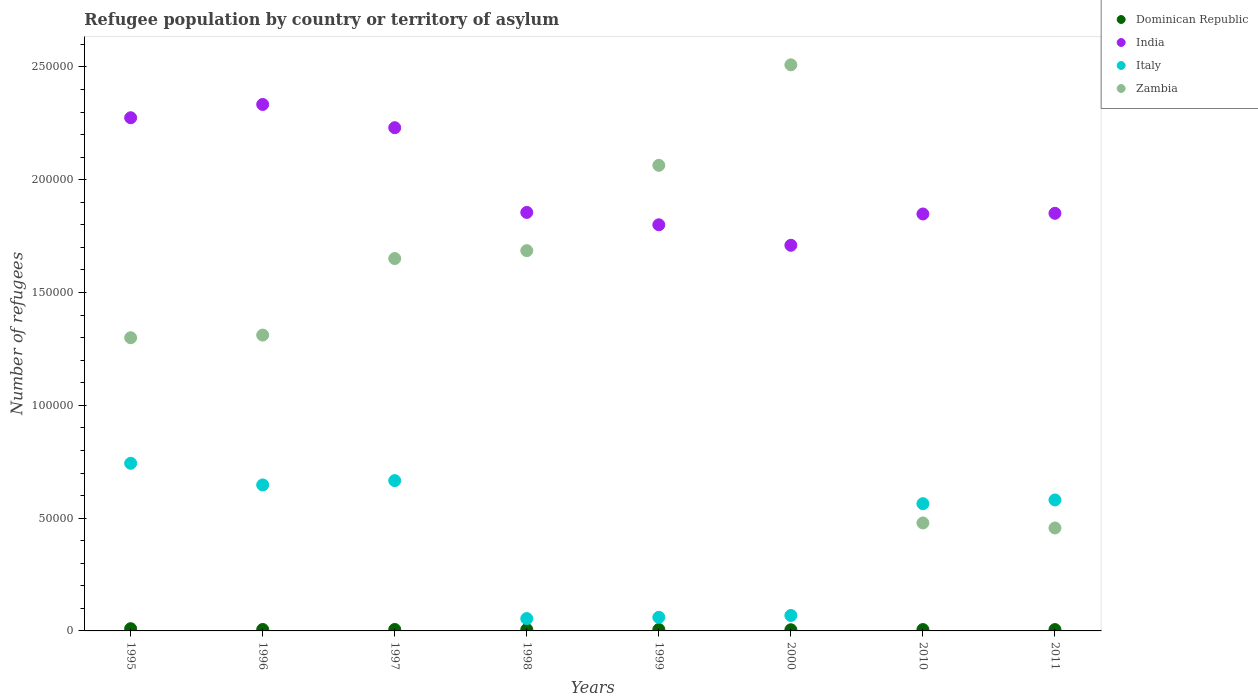How many different coloured dotlines are there?
Ensure brevity in your answer.  4. Is the number of dotlines equal to the number of legend labels?
Make the answer very short. Yes. What is the number of refugees in Zambia in 1998?
Your answer should be compact. 1.69e+05. Across all years, what is the maximum number of refugees in Italy?
Ensure brevity in your answer.  7.43e+04. Across all years, what is the minimum number of refugees in India?
Provide a short and direct response. 1.71e+05. In which year was the number of refugees in Zambia minimum?
Your answer should be very brief. 2011. What is the total number of refugees in Dominican Republic in the graph?
Offer a very short reply. 5206. What is the difference between the number of refugees in Zambia in 1999 and that in 2000?
Offer a very short reply. -4.46e+04. What is the difference between the number of refugees in Italy in 1999 and the number of refugees in India in 2000?
Keep it short and to the point. -1.65e+05. What is the average number of refugees in Dominican Republic per year?
Keep it short and to the point. 650.75. In the year 2011, what is the difference between the number of refugees in Italy and number of refugees in India?
Ensure brevity in your answer.  -1.27e+05. In how many years, is the number of refugees in Italy greater than 220000?
Ensure brevity in your answer.  0. What is the ratio of the number of refugees in Italy in 1999 to that in 2000?
Offer a terse response. 0.88. Is the number of refugees in Zambia in 1996 less than that in 2010?
Your answer should be very brief. No. Is the difference between the number of refugees in Italy in 1999 and 2000 greater than the difference between the number of refugees in India in 1999 and 2000?
Give a very brief answer. No. What is the difference between the highest and the second highest number of refugees in Italy?
Give a very brief answer. 7682. What is the difference between the highest and the lowest number of refugees in India?
Give a very brief answer. 6.24e+04. In how many years, is the number of refugees in India greater than the average number of refugees in India taken over all years?
Give a very brief answer. 3. Is it the case that in every year, the sum of the number of refugees in Zambia and number of refugees in India  is greater than the sum of number of refugees in Dominican Republic and number of refugees in Italy?
Offer a terse response. No. Does the number of refugees in Zambia monotonically increase over the years?
Keep it short and to the point. No. Is the number of refugees in Zambia strictly greater than the number of refugees in Italy over the years?
Your answer should be very brief. No. How many years are there in the graph?
Offer a terse response. 8. Does the graph contain any zero values?
Provide a short and direct response. No. What is the title of the graph?
Offer a terse response. Refugee population by country or territory of asylum. What is the label or title of the Y-axis?
Make the answer very short. Number of refugees. What is the Number of refugees in Dominican Republic in 1995?
Keep it short and to the point. 985. What is the Number of refugees of India in 1995?
Your answer should be very brief. 2.27e+05. What is the Number of refugees of Italy in 1995?
Provide a short and direct response. 7.43e+04. What is the Number of refugees in Zambia in 1995?
Your answer should be very brief. 1.30e+05. What is the Number of refugees in Dominican Republic in 1996?
Offer a terse response. 640. What is the Number of refugees of India in 1996?
Make the answer very short. 2.33e+05. What is the Number of refugees of Italy in 1996?
Keep it short and to the point. 6.47e+04. What is the Number of refugees of Zambia in 1996?
Make the answer very short. 1.31e+05. What is the Number of refugees in Dominican Republic in 1997?
Your answer should be very brief. 638. What is the Number of refugees in India in 1997?
Offer a very short reply. 2.23e+05. What is the Number of refugees in Italy in 1997?
Provide a short and direct response. 6.66e+04. What is the Number of refugees in Zambia in 1997?
Offer a terse response. 1.65e+05. What is the Number of refugees in Dominican Republic in 1998?
Offer a very short reply. 614. What is the Number of refugees in India in 1998?
Offer a terse response. 1.86e+05. What is the Number of refugees in Italy in 1998?
Provide a succinct answer. 5473. What is the Number of refugees in Zambia in 1998?
Your answer should be compact. 1.69e+05. What is the Number of refugees of Dominican Republic in 1999?
Offer a terse response. 625. What is the Number of refugees of India in 1999?
Your response must be concise. 1.80e+05. What is the Number of refugees in Italy in 1999?
Your response must be concise. 6024. What is the Number of refugees of Zambia in 1999?
Provide a succinct answer. 2.06e+05. What is the Number of refugees in Dominican Republic in 2000?
Your answer should be very brief. 510. What is the Number of refugees in India in 2000?
Your response must be concise. 1.71e+05. What is the Number of refugees of Italy in 2000?
Ensure brevity in your answer.  6849. What is the Number of refugees in Zambia in 2000?
Your response must be concise. 2.51e+05. What is the Number of refugees in Dominican Republic in 2010?
Provide a succinct answer. 599. What is the Number of refugees of India in 2010?
Keep it short and to the point. 1.85e+05. What is the Number of refugees of Italy in 2010?
Give a very brief answer. 5.64e+04. What is the Number of refugees of Zambia in 2010?
Offer a terse response. 4.79e+04. What is the Number of refugees of Dominican Republic in 2011?
Provide a succinct answer. 595. What is the Number of refugees in India in 2011?
Your answer should be compact. 1.85e+05. What is the Number of refugees of Italy in 2011?
Offer a very short reply. 5.81e+04. What is the Number of refugees of Zambia in 2011?
Ensure brevity in your answer.  4.56e+04. Across all years, what is the maximum Number of refugees of Dominican Republic?
Offer a terse response. 985. Across all years, what is the maximum Number of refugees of India?
Provide a succinct answer. 2.33e+05. Across all years, what is the maximum Number of refugees in Italy?
Give a very brief answer. 7.43e+04. Across all years, what is the maximum Number of refugees of Zambia?
Offer a very short reply. 2.51e+05. Across all years, what is the minimum Number of refugees of Dominican Republic?
Your answer should be very brief. 510. Across all years, what is the minimum Number of refugees in India?
Offer a terse response. 1.71e+05. Across all years, what is the minimum Number of refugees of Italy?
Your answer should be compact. 5473. Across all years, what is the minimum Number of refugees in Zambia?
Keep it short and to the point. 4.56e+04. What is the total Number of refugees in Dominican Republic in the graph?
Offer a very short reply. 5206. What is the total Number of refugees of India in the graph?
Your answer should be compact. 1.59e+06. What is the total Number of refugees of Italy in the graph?
Your answer should be compact. 3.38e+05. What is the total Number of refugees in Zambia in the graph?
Your answer should be very brief. 1.15e+06. What is the difference between the Number of refugees of Dominican Republic in 1995 and that in 1996?
Your answer should be compact. 345. What is the difference between the Number of refugees of India in 1995 and that in 1996?
Your answer should be very brief. -5890. What is the difference between the Number of refugees of Italy in 1995 and that in 1996?
Provide a short and direct response. 9591. What is the difference between the Number of refugees of Zambia in 1995 and that in 1996?
Your answer should be very brief. -1174. What is the difference between the Number of refugees in Dominican Republic in 1995 and that in 1997?
Give a very brief answer. 347. What is the difference between the Number of refugees of India in 1995 and that in 1997?
Keep it short and to the point. 4407. What is the difference between the Number of refugees of Italy in 1995 and that in 1997?
Ensure brevity in your answer.  7682. What is the difference between the Number of refugees in Zambia in 1995 and that in 1997?
Your answer should be compact. -3.51e+04. What is the difference between the Number of refugees in Dominican Republic in 1995 and that in 1998?
Offer a terse response. 371. What is the difference between the Number of refugees in India in 1995 and that in 1998?
Your answer should be very brief. 4.20e+04. What is the difference between the Number of refugees in Italy in 1995 and that in 1998?
Offer a terse response. 6.88e+04. What is the difference between the Number of refugees of Zambia in 1995 and that in 1998?
Ensure brevity in your answer.  -3.86e+04. What is the difference between the Number of refugees in Dominican Republic in 1995 and that in 1999?
Offer a very short reply. 360. What is the difference between the Number of refugees in India in 1995 and that in 1999?
Offer a terse response. 4.74e+04. What is the difference between the Number of refugees in Italy in 1995 and that in 1999?
Keep it short and to the point. 6.83e+04. What is the difference between the Number of refugees in Zambia in 1995 and that in 1999?
Your answer should be very brief. -7.64e+04. What is the difference between the Number of refugees in Dominican Republic in 1995 and that in 2000?
Give a very brief answer. 475. What is the difference between the Number of refugees of India in 1995 and that in 2000?
Provide a succinct answer. 5.65e+04. What is the difference between the Number of refugees in Italy in 1995 and that in 2000?
Provide a short and direct response. 6.75e+04. What is the difference between the Number of refugees of Zambia in 1995 and that in 2000?
Your answer should be compact. -1.21e+05. What is the difference between the Number of refugees in Dominican Republic in 1995 and that in 2010?
Provide a succinct answer. 386. What is the difference between the Number of refugees in India in 1995 and that in 2010?
Your answer should be very brief. 4.27e+04. What is the difference between the Number of refugees of Italy in 1995 and that in 2010?
Your response must be concise. 1.79e+04. What is the difference between the Number of refugees in Zambia in 1995 and that in 2010?
Give a very brief answer. 8.21e+04. What is the difference between the Number of refugees of Dominican Republic in 1995 and that in 2011?
Your response must be concise. 390. What is the difference between the Number of refugees in India in 1995 and that in 2011?
Give a very brief answer. 4.24e+04. What is the difference between the Number of refugees in Italy in 1995 and that in 2011?
Your answer should be compact. 1.62e+04. What is the difference between the Number of refugees in Zambia in 1995 and that in 2011?
Ensure brevity in your answer.  8.43e+04. What is the difference between the Number of refugees of Dominican Republic in 1996 and that in 1997?
Keep it short and to the point. 2. What is the difference between the Number of refugees of India in 1996 and that in 1997?
Make the answer very short. 1.03e+04. What is the difference between the Number of refugees of Italy in 1996 and that in 1997?
Offer a terse response. -1909. What is the difference between the Number of refugees in Zambia in 1996 and that in 1997?
Provide a short and direct response. -3.39e+04. What is the difference between the Number of refugees in Dominican Republic in 1996 and that in 1998?
Offer a terse response. 26. What is the difference between the Number of refugees of India in 1996 and that in 1998?
Provide a short and direct response. 4.79e+04. What is the difference between the Number of refugees in Italy in 1996 and that in 1998?
Offer a very short reply. 5.92e+04. What is the difference between the Number of refugees in Zambia in 1996 and that in 1998?
Give a very brief answer. -3.74e+04. What is the difference between the Number of refugees of India in 1996 and that in 1999?
Offer a terse response. 5.33e+04. What is the difference between the Number of refugees in Italy in 1996 and that in 1999?
Keep it short and to the point. 5.87e+04. What is the difference between the Number of refugees of Zambia in 1996 and that in 1999?
Provide a short and direct response. -7.52e+04. What is the difference between the Number of refugees of Dominican Republic in 1996 and that in 2000?
Ensure brevity in your answer.  130. What is the difference between the Number of refugees of India in 1996 and that in 2000?
Provide a short and direct response. 6.24e+04. What is the difference between the Number of refugees in Italy in 1996 and that in 2000?
Your response must be concise. 5.79e+04. What is the difference between the Number of refugees in Zambia in 1996 and that in 2000?
Your answer should be compact. -1.20e+05. What is the difference between the Number of refugees of India in 1996 and that in 2010?
Offer a very short reply. 4.85e+04. What is the difference between the Number of refugees in Italy in 1996 and that in 2010?
Provide a short and direct response. 8314. What is the difference between the Number of refugees in Zambia in 1996 and that in 2010?
Offer a very short reply. 8.33e+04. What is the difference between the Number of refugees in India in 1996 and that in 2011?
Give a very brief answer. 4.83e+04. What is the difference between the Number of refugees in Italy in 1996 and that in 2011?
Your response must be concise. 6651. What is the difference between the Number of refugees of Zambia in 1996 and that in 2011?
Give a very brief answer. 8.55e+04. What is the difference between the Number of refugees of Dominican Republic in 1997 and that in 1998?
Your answer should be compact. 24. What is the difference between the Number of refugees in India in 1997 and that in 1998?
Your answer should be compact. 3.76e+04. What is the difference between the Number of refugees in Italy in 1997 and that in 1998?
Keep it short and to the point. 6.11e+04. What is the difference between the Number of refugees of Zambia in 1997 and that in 1998?
Your answer should be very brief. -3492. What is the difference between the Number of refugees in Dominican Republic in 1997 and that in 1999?
Provide a short and direct response. 13. What is the difference between the Number of refugees of India in 1997 and that in 1999?
Your answer should be very brief. 4.30e+04. What is the difference between the Number of refugees in Italy in 1997 and that in 1999?
Provide a succinct answer. 6.06e+04. What is the difference between the Number of refugees of Zambia in 1997 and that in 1999?
Your answer should be very brief. -4.13e+04. What is the difference between the Number of refugees of Dominican Republic in 1997 and that in 2000?
Keep it short and to the point. 128. What is the difference between the Number of refugees of India in 1997 and that in 2000?
Offer a terse response. 5.21e+04. What is the difference between the Number of refugees of Italy in 1997 and that in 2000?
Your response must be concise. 5.98e+04. What is the difference between the Number of refugees in Zambia in 1997 and that in 2000?
Keep it short and to the point. -8.59e+04. What is the difference between the Number of refugees of India in 1997 and that in 2010?
Offer a terse response. 3.83e+04. What is the difference between the Number of refugees of Italy in 1997 and that in 2010?
Your answer should be compact. 1.02e+04. What is the difference between the Number of refugees of Zambia in 1997 and that in 2010?
Ensure brevity in your answer.  1.17e+05. What is the difference between the Number of refugees of Dominican Republic in 1997 and that in 2011?
Make the answer very short. 43. What is the difference between the Number of refugees in India in 1997 and that in 2011?
Provide a short and direct response. 3.80e+04. What is the difference between the Number of refugees in Italy in 1997 and that in 2011?
Offer a terse response. 8560. What is the difference between the Number of refugees in Zambia in 1997 and that in 2011?
Provide a short and direct response. 1.19e+05. What is the difference between the Number of refugees in Dominican Republic in 1998 and that in 1999?
Offer a very short reply. -11. What is the difference between the Number of refugees of India in 1998 and that in 1999?
Ensure brevity in your answer.  5485. What is the difference between the Number of refugees of Italy in 1998 and that in 1999?
Offer a terse response. -551. What is the difference between the Number of refugees in Zambia in 1998 and that in 1999?
Your response must be concise. -3.78e+04. What is the difference between the Number of refugees in Dominican Republic in 1998 and that in 2000?
Your answer should be compact. 104. What is the difference between the Number of refugees of India in 1998 and that in 2000?
Keep it short and to the point. 1.46e+04. What is the difference between the Number of refugees in Italy in 1998 and that in 2000?
Your response must be concise. -1376. What is the difference between the Number of refugees of Zambia in 1998 and that in 2000?
Provide a short and direct response. -8.24e+04. What is the difference between the Number of refugees of India in 1998 and that in 2010?
Offer a terse response. 695. What is the difference between the Number of refugees in Italy in 1998 and that in 2010?
Your answer should be compact. -5.09e+04. What is the difference between the Number of refugees of Zambia in 1998 and that in 2010?
Make the answer very short. 1.21e+05. What is the difference between the Number of refugees of India in 1998 and that in 2011?
Your answer should be very brief. 398. What is the difference between the Number of refugees in Italy in 1998 and that in 2011?
Ensure brevity in your answer.  -5.26e+04. What is the difference between the Number of refugees in Zambia in 1998 and that in 2011?
Make the answer very short. 1.23e+05. What is the difference between the Number of refugees of Dominican Republic in 1999 and that in 2000?
Your response must be concise. 115. What is the difference between the Number of refugees in India in 1999 and that in 2000?
Offer a terse response. 9090. What is the difference between the Number of refugees in Italy in 1999 and that in 2000?
Your answer should be compact. -825. What is the difference between the Number of refugees of Zambia in 1999 and that in 2000?
Your response must be concise. -4.46e+04. What is the difference between the Number of refugees in Dominican Republic in 1999 and that in 2010?
Your answer should be compact. 26. What is the difference between the Number of refugees of India in 1999 and that in 2010?
Your answer should be very brief. -4790. What is the difference between the Number of refugees in Italy in 1999 and that in 2010?
Provide a short and direct response. -5.04e+04. What is the difference between the Number of refugees in Zambia in 1999 and that in 2010?
Give a very brief answer. 1.59e+05. What is the difference between the Number of refugees of Dominican Republic in 1999 and that in 2011?
Your answer should be compact. 30. What is the difference between the Number of refugees of India in 1999 and that in 2011?
Keep it short and to the point. -5087. What is the difference between the Number of refugees in Italy in 1999 and that in 2011?
Keep it short and to the point. -5.20e+04. What is the difference between the Number of refugees in Zambia in 1999 and that in 2011?
Keep it short and to the point. 1.61e+05. What is the difference between the Number of refugees in Dominican Republic in 2000 and that in 2010?
Offer a terse response. -89. What is the difference between the Number of refugees in India in 2000 and that in 2010?
Your answer should be compact. -1.39e+04. What is the difference between the Number of refugees of Italy in 2000 and that in 2010?
Provide a succinct answer. -4.95e+04. What is the difference between the Number of refugees of Zambia in 2000 and that in 2010?
Your answer should be very brief. 2.03e+05. What is the difference between the Number of refugees in Dominican Republic in 2000 and that in 2011?
Provide a succinct answer. -85. What is the difference between the Number of refugees of India in 2000 and that in 2011?
Ensure brevity in your answer.  -1.42e+04. What is the difference between the Number of refugees in Italy in 2000 and that in 2011?
Your answer should be compact. -5.12e+04. What is the difference between the Number of refugees of Zambia in 2000 and that in 2011?
Give a very brief answer. 2.05e+05. What is the difference between the Number of refugees of India in 2010 and that in 2011?
Provide a succinct answer. -297. What is the difference between the Number of refugees of Italy in 2010 and that in 2011?
Ensure brevity in your answer.  -1663. What is the difference between the Number of refugees in Zambia in 2010 and that in 2011?
Make the answer very short. 2225. What is the difference between the Number of refugees of Dominican Republic in 1995 and the Number of refugees of India in 1996?
Your response must be concise. -2.32e+05. What is the difference between the Number of refugees of Dominican Republic in 1995 and the Number of refugees of Italy in 1996?
Ensure brevity in your answer.  -6.37e+04. What is the difference between the Number of refugees of Dominican Republic in 1995 and the Number of refugees of Zambia in 1996?
Offer a very short reply. -1.30e+05. What is the difference between the Number of refugees in India in 1995 and the Number of refugees in Italy in 1996?
Offer a very short reply. 1.63e+05. What is the difference between the Number of refugees of India in 1995 and the Number of refugees of Zambia in 1996?
Give a very brief answer. 9.63e+04. What is the difference between the Number of refugees in Italy in 1995 and the Number of refugees in Zambia in 1996?
Ensure brevity in your answer.  -5.68e+04. What is the difference between the Number of refugees of Dominican Republic in 1995 and the Number of refugees of India in 1997?
Your answer should be very brief. -2.22e+05. What is the difference between the Number of refugees in Dominican Republic in 1995 and the Number of refugees in Italy in 1997?
Your answer should be compact. -6.56e+04. What is the difference between the Number of refugees of Dominican Republic in 1995 and the Number of refugees of Zambia in 1997?
Offer a very short reply. -1.64e+05. What is the difference between the Number of refugees of India in 1995 and the Number of refugees of Italy in 1997?
Your answer should be very brief. 1.61e+05. What is the difference between the Number of refugees in India in 1995 and the Number of refugees in Zambia in 1997?
Keep it short and to the point. 6.24e+04. What is the difference between the Number of refugees of Italy in 1995 and the Number of refugees of Zambia in 1997?
Keep it short and to the point. -9.08e+04. What is the difference between the Number of refugees in Dominican Republic in 1995 and the Number of refugees in India in 1998?
Your answer should be very brief. -1.85e+05. What is the difference between the Number of refugees of Dominican Republic in 1995 and the Number of refugees of Italy in 1998?
Make the answer very short. -4488. What is the difference between the Number of refugees of Dominican Republic in 1995 and the Number of refugees of Zambia in 1998?
Offer a terse response. -1.68e+05. What is the difference between the Number of refugees in India in 1995 and the Number of refugees in Italy in 1998?
Your answer should be very brief. 2.22e+05. What is the difference between the Number of refugees in India in 1995 and the Number of refugees in Zambia in 1998?
Your response must be concise. 5.89e+04. What is the difference between the Number of refugees of Italy in 1995 and the Number of refugees of Zambia in 1998?
Offer a terse response. -9.43e+04. What is the difference between the Number of refugees in Dominican Republic in 1995 and the Number of refugees in India in 1999?
Your answer should be very brief. -1.79e+05. What is the difference between the Number of refugees of Dominican Republic in 1995 and the Number of refugees of Italy in 1999?
Make the answer very short. -5039. What is the difference between the Number of refugees of Dominican Republic in 1995 and the Number of refugees of Zambia in 1999?
Offer a very short reply. -2.05e+05. What is the difference between the Number of refugees in India in 1995 and the Number of refugees in Italy in 1999?
Your answer should be compact. 2.21e+05. What is the difference between the Number of refugees of India in 1995 and the Number of refugees of Zambia in 1999?
Keep it short and to the point. 2.11e+04. What is the difference between the Number of refugees of Italy in 1995 and the Number of refugees of Zambia in 1999?
Offer a terse response. -1.32e+05. What is the difference between the Number of refugees in Dominican Republic in 1995 and the Number of refugees in India in 2000?
Offer a very short reply. -1.70e+05. What is the difference between the Number of refugees in Dominican Republic in 1995 and the Number of refugees in Italy in 2000?
Provide a short and direct response. -5864. What is the difference between the Number of refugees in Dominican Republic in 1995 and the Number of refugees in Zambia in 2000?
Make the answer very short. -2.50e+05. What is the difference between the Number of refugees of India in 1995 and the Number of refugees of Italy in 2000?
Your response must be concise. 2.21e+05. What is the difference between the Number of refugees in India in 1995 and the Number of refugees in Zambia in 2000?
Make the answer very short. -2.35e+04. What is the difference between the Number of refugees of Italy in 1995 and the Number of refugees of Zambia in 2000?
Provide a short and direct response. -1.77e+05. What is the difference between the Number of refugees in Dominican Republic in 1995 and the Number of refugees in India in 2010?
Give a very brief answer. -1.84e+05. What is the difference between the Number of refugees in Dominican Republic in 1995 and the Number of refugees in Italy in 2010?
Your answer should be compact. -5.54e+04. What is the difference between the Number of refugees in Dominican Republic in 1995 and the Number of refugees in Zambia in 2010?
Make the answer very short. -4.69e+04. What is the difference between the Number of refugees in India in 1995 and the Number of refugees in Italy in 2010?
Your answer should be very brief. 1.71e+05. What is the difference between the Number of refugees in India in 1995 and the Number of refugees in Zambia in 2010?
Provide a succinct answer. 1.80e+05. What is the difference between the Number of refugees in Italy in 1995 and the Number of refugees in Zambia in 2010?
Offer a terse response. 2.64e+04. What is the difference between the Number of refugees of Dominican Republic in 1995 and the Number of refugees of India in 2011?
Provide a short and direct response. -1.84e+05. What is the difference between the Number of refugees of Dominican Republic in 1995 and the Number of refugees of Italy in 2011?
Keep it short and to the point. -5.71e+04. What is the difference between the Number of refugees of Dominican Republic in 1995 and the Number of refugees of Zambia in 2011?
Offer a terse response. -4.46e+04. What is the difference between the Number of refugees of India in 1995 and the Number of refugees of Italy in 2011?
Keep it short and to the point. 1.69e+05. What is the difference between the Number of refugees of India in 1995 and the Number of refugees of Zambia in 2011?
Give a very brief answer. 1.82e+05. What is the difference between the Number of refugees of Italy in 1995 and the Number of refugees of Zambia in 2011?
Your answer should be compact. 2.87e+04. What is the difference between the Number of refugees of Dominican Republic in 1996 and the Number of refugees of India in 1997?
Offer a very short reply. -2.22e+05. What is the difference between the Number of refugees in Dominican Republic in 1996 and the Number of refugees in Italy in 1997?
Ensure brevity in your answer.  -6.60e+04. What is the difference between the Number of refugees in Dominican Republic in 1996 and the Number of refugees in Zambia in 1997?
Offer a terse response. -1.64e+05. What is the difference between the Number of refugees of India in 1996 and the Number of refugees of Italy in 1997?
Give a very brief answer. 1.67e+05. What is the difference between the Number of refugees of India in 1996 and the Number of refugees of Zambia in 1997?
Your answer should be compact. 6.83e+04. What is the difference between the Number of refugees in Italy in 1996 and the Number of refugees in Zambia in 1997?
Offer a very short reply. -1.00e+05. What is the difference between the Number of refugees of Dominican Republic in 1996 and the Number of refugees of India in 1998?
Ensure brevity in your answer.  -1.85e+05. What is the difference between the Number of refugees of Dominican Republic in 1996 and the Number of refugees of Italy in 1998?
Ensure brevity in your answer.  -4833. What is the difference between the Number of refugees of Dominican Republic in 1996 and the Number of refugees of Zambia in 1998?
Offer a very short reply. -1.68e+05. What is the difference between the Number of refugees of India in 1996 and the Number of refugees of Italy in 1998?
Make the answer very short. 2.28e+05. What is the difference between the Number of refugees in India in 1996 and the Number of refugees in Zambia in 1998?
Your answer should be very brief. 6.48e+04. What is the difference between the Number of refugees in Italy in 1996 and the Number of refugees in Zambia in 1998?
Offer a very short reply. -1.04e+05. What is the difference between the Number of refugees of Dominican Republic in 1996 and the Number of refugees of India in 1999?
Your answer should be very brief. -1.79e+05. What is the difference between the Number of refugees of Dominican Republic in 1996 and the Number of refugees of Italy in 1999?
Provide a short and direct response. -5384. What is the difference between the Number of refugees of Dominican Republic in 1996 and the Number of refugees of Zambia in 1999?
Your answer should be very brief. -2.06e+05. What is the difference between the Number of refugees of India in 1996 and the Number of refugees of Italy in 1999?
Provide a short and direct response. 2.27e+05. What is the difference between the Number of refugees of India in 1996 and the Number of refugees of Zambia in 1999?
Make the answer very short. 2.70e+04. What is the difference between the Number of refugees in Italy in 1996 and the Number of refugees in Zambia in 1999?
Provide a short and direct response. -1.42e+05. What is the difference between the Number of refugees of Dominican Republic in 1996 and the Number of refugees of India in 2000?
Make the answer very short. -1.70e+05. What is the difference between the Number of refugees in Dominican Republic in 1996 and the Number of refugees in Italy in 2000?
Your answer should be very brief. -6209. What is the difference between the Number of refugees of Dominican Republic in 1996 and the Number of refugees of Zambia in 2000?
Provide a succinct answer. -2.50e+05. What is the difference between the Number of refugees of India in 1996 and the Number of refugees of Italy in 2000?
Provide a short and direct response. 2.27e+05. What is the difference between the Number of refugees of India in 1996 and the Number of refugees of Zambia in 2000?
Give a very brief answer. -1.76e+04. What is the difference between the Number of refugees of Italy in 1996 and the Number of refugees of Zambia in 2000?
Offer a very short reply. -1.86e+05. What is the difference between the Number of refugees in Dominican Republic in 1996 and the Number of refugees in India in 2010?
Your answer should be very brief. -1.84e+05. What is the difference between the Number of refugees in Dominican Republic in 1996 and the Number of refugees in Italy in 2010?
Offer a terse response. -5.58e+04. What is the difference between the Number of refugees in Dominican Republic in 1996 and the Number of refugees in Zambia in 2010?
Keep it short and to the point. -4.72e+04. What is the difference between the Number of refugees in India in 1996 and the Number of refugees in Italy in 2010?
Give a very brief answer. 1.77e+05. What is the difference between the Number of refugees in India in 1996 and the Number of refugees in Zambia in 2010?
Provide a short and direct response. 1.86e+05. What is the difference between the Number of refugees of Italy in 1996 and the Number of refugees of Zambia in 2010?
Your response must be concise. 1.69e+04. What is the difference between the Number of refugees in Dominican Republic in 1996 and the Number of refugees in India in 2011?
Ensure brevity in your answer.  -1.84e+05. What is the difference between the Number of refugees in Dominican Republic in 1996 and the Number of refugees in Italy in 2011?
Provide a short and direct response. -5.74e+04. What is the difference between the Number of refugees of Dominican Republic in 1996 and the Number of refugees of Zambia in 2011?
Give a very brief answer. -4.50e+04. What is the difference between the Number of refugees in India in 1996 and the Number of refugees in Italy in 2011?
Provide a succinct answer. 1.75e+05. What is the difference between the Number of refugees of India in 1996 and the Number of refugees of Zambia in 2011?
Provide a succinct answer. 1.88e+05. What is the difference between the Number of refugees of Italy in 1996 and the Number of refugees of Zambia in 2011?
Give a very brief answer. 1.91e+04. What is the difference between the Number of refugees in Dominican Republic in 1997 and the Number of refugees in India in 1998?
Provide a succinct answer. -1.85e+05. What is the difference between the Number of refugees of Dominican Republic in 1997 and the Number of refugees of Italy in 1998?
Provide a short and direct response. -4835. What is the difference between the Number of refugees of Dominican Republic in 1997 and the Number of refugees of Zambia in 1998?
Keep it short and to the point. -1.68e+05. What is the difference between the Number of refugees of India in 1997 and the Number of refugees of Italy in 1998?
Ensure brevity in your answer.  2.18e+05. What is the difference between the Number of refugees in India in 1997 and the Number of refugees in Zambia in 1998?
Your response must be concise. 5.45e+04. What is the difference between the Number of refugees of Italy in 1997 and the Number of refugees of Zambia in 1998?
Offer a very short reply. -1.02e+05. What is the difference between the Number of refugees of Dominican Republic in 1997 and the Number of refugees of India in 1999?
Provide a succinct answer. -1.79e+05. What is the difference between the Number of refugees of Dominican Republic in 1997 and the Number of refugees of Italy in 1999?
Offer a very short reply. -5386. What is the difference between the Number of refugees in Dominican Republic in 1997 and the Number of refugees in Zambia in 1999?
Provide a succinct answer. -2.06e+05. What is the difference between the Number of refugees of India in 1997 and the Number of refugees of Italy in 1999?
Your answer should be very brief. 2.17e+05. What is the difference between the Number of refugees of India in 1997 and the Number of refugees of Zambia in 1999?
Provide a short and direct response. 1.67e+04. What is the difference between the Number of refugees in Italy in 1997 and the Number of refugees in Zambia in 1999?
Make the answer very short. -1.40e+05. What is the difference between the Number of refugees of Dominican Republic in 1997 and the Number of refugees of India in 2000?
Offer a very short reply. -1.70e+05. What is the difference between the Number of refugees in Dominican Republic in 1997 and the Number of refugees in Italy in 2000?
Offer a terse response. -6211. What is the difference between the Number of refugees of Dominican Republic in 1997 and the Number of refugees of Zambia in 2000?
Your answer should be very brief. -2.50e+05. What is the difference between the Number of refugees of India in 1997 and the Number of refugees of Italy in 2000?
Offer a very short reply. 2.16e+05. What is the difference between the Number of refugees in India in 1997 and the Number of refugees in Zambia in 2000?
Give a very brief answer. -2.79e+04. What is the difference between the Number of refugees of Italy in 1997 and the Number of refugees of Zambia in 2000?
Keep it short and to the point. -1.84e+05. What is the difference between the Number of refugees in Dominican Republic in 1997 and the Number of refugees in India in 2010?
Ensure brevity in your answer.  -1.84e+05. What is the difference between the Number of refugees in Dominican Republic in 1997 and the Number of refugees in Italy in 2010?
Provide a short and direct response. -5.58e+04. What is the difference between the Number of refugees in Dominican Republic in 1997 and the Number of refugees in Zambia in 2010?
Your response must be concise. -4.72e+04. What is the difference between the Number of refugees of India in 1997 and the Number of refugees of Italy in 2010?
Your answer should be compact. 1.67e+05. What is the difference between the Number of refugees in India in 1997 and the Number of refugees in Zambia in 2010?
Give a very brief answer. 1.75e+05. What is the difference between the Number of refugees in Italy in 1997 and the Number of refugees in Zambia in 2010?
Make the answer very short. 1.88e+04. What is the difference between the Number of refugees of Dominican Republic in 1997 and the Number of refugees of India in 2011?
Make the answer very short. -1.84e+05. What is the difference between the Number of refugees of Dominican Republic in 1997 and the Number of refugees of Italy in 2011?
Ensure brevity in your answer.  -5.74e+04. What is the difference between the Number of refugees of Dominican Republic in 1997 and the Number of refugees of Zambia in 2011?
Your answer should be very brief. -4.50e+04. What is the difference between the Number of refugees in India in 1997 and the Number of refugees in Italy in 2011?
Offer a terse response. 1.65e+05. What is the difference between the Number of refugees in India in 1997 and the Number of refugees in Zambia in 2011?
Your answer should be compact. 1.77e+05. What is the difference between the Number of refugees of Italy in 1997 and the Number of refugees of Zambia in 2011?
Offer a very short reply. 2.10e+04. What is the difference between the Number of refugees of Dominican Republic in 1998 and the Number of refugees of India in 1999?
Offer a very short reply. -1.79e+05. What is the difference between the Number of refugees of Dominican Republic in 1998 and the Number of refugees of Italy in 1999?
Provide a succinct answer. -5410. What is the difference between the Number of refugees in Dominican Republic in 1998 and the Number of refugees in Zambia in 1999?
Give a very brief answer. -2.06e+05. What is the difference between the Number of refugees of India in 1998 and the Number of refugees of Italy in 1999?
Ensure brevity in your answer.  1.79e+05. What is the difference between the Number of refugees in India in 1998 and the Number of refugees in Zambia in 1999?
Keep it short and to the point. -2.09e+04. What is the difference between the Number of refugees in Italy in 1998 and the Number of refugees in Zambia in 1999?
Your response must be concise. -2.01e+05. What is the difference between the Number of refugees of Dominican Republic in 1998 and the Number of refugees of India in 2000?
Your answer should be compact. -1.70e+05. What is the difference between the Number of refugees in Dominican Republic in 1998 and the Number of refugees in Italy in 2000?
Provide a succinct answer. -6235. What is the difference between the Number of refugees in Dominican Republic in 1998 and the Number of refugees in Zambia in 2000?
Your answer should be very brief. -2.50e+05. What is the difference between the Number of refugees in India in 1998 and the Number of refugees in Italy in 2000?
Make the answer very short. 1.79e+05. What is the difference between the Number of refugees of India in 1998 and the Number of refugees of Zambia in 2000?
Offer a terse response. -6.54e+04. What is the difference between the Number of refugees in Italy in 1998 and the Number of refugees in Zambia in 2000?
Offer a very short reply. -2.45e+05. What is the difference between the Number of refugees of Dominican Republic in 1998 and the Number of refugees of India in 2010?
Provide a short and direct response. -1.84e+05. What is the difference between the Number of refugees in Dominican Republic in 1998 and the Number of refugees in Italy in 2010?
Keep it short and to the point. -5.58e+04. What is the difference between the Number of refugees in Dominican Republic in 1998 and the Number of refugees in Zambia in 2010?
Ensure brevity in your answer.  -4.72e+04. What is the difference between the Number of refugees in India in 1998 and the Number of refugees in Italy in 2010?
Provide a short and direct response. 1.29e+05. What is the difference between the Number of refugees of India in 1998 and the Number of refugees of Zambia in 2010?
Make the answer very short. 1.38e+05. What is the difference between the Number of refugees of Italy in 1998 and the Number of refugees of Zambia in 2010?
Give a very brief answer. -4.24e+04. What is the difference between the Number of refugees in Dominican Republic in 1998 and the Number of refugees in India in 2011?
Make the answer very short. -1.85e+05. What is the difference between the Number of refugees in Dominican Republic in 1998 and the Number of refugees in Italy in 2011?
Provide a succinct answer. -5.74e+04. What is the difference between the Number of refugees in Dominican Republic in 1998 and the Number of refugees in Zambia in 2011?
Give a very brief answer. -4.50e+04. What is the difference between the Number of refugees in India in 1998 and the Number of refugees in Italy in 2011?
Your answer should be very brief. 1.27e+05. What is the difference between the Number of refugees of India in 1998 and the Number of refugees of Zambia in 2011?
Offer a terse response. 1.40e+05. What is the difference between the Number of refugees of Italy in 1998 and the Number of refugees of Zambia in 2011?
Offer a very short reply. -4.02e+04. What is the difference between the Number of refugees in Dominican Republic in 1999 and the Number of refugees in India in 2000?
Ensure brevity in your answer.  -1.70e+05. What is the difference between the Number of refugees of Dominican Republic in 1999 and the Number of refugees of Italy in 2000?
Your answer should be very brief. -6224. What is the difference between the Number of refugees of Dominican Republic in 1999 and the Number of refugees of Zambia in 2000?
Your answer should be very brief. -2.50e+05. What is the difference between the Number of refugees in India in 1999 and the Number of refugees in Italy in 2000?
Your response must be concise. 1.73e+05. What is the difference between the Number of refugees in India in 1999 and the Number of refugees in Zambia in 2000?
Make the answer very short. -7.09e+04. What is the difference between the Number of refugees of Italy in 1999 and the Number of refugees of Zambia in 2000?
Offer a terse response. -2.45e+05. What is the difference between the Number of refugees in Dominican Republic in 1999 and the Number of refugees in India in 2010?
Give a very brief answer. -1.84e+05. What is the difference between the Number of refugees in Dominican Republic in 1999 and the Number of refugees in Italy in 2010?
Your answer should be compact. -5.58e+04. What is the difference between the Number of refugees in Dominican Republic in 1999 and the Number of refugees in Zambia in 2010?
Your response must be concise. -4.72e+04. What is the difference between the Number of refugees of India in 1999 and the Number of refugees of Italy in 2010?
Your answer should be very brief. 1.24e+05. What is the difference between the Number of refugees of India in 1999 and the Number of refugees of Zambia in 2010?
Your answer should be compact. 1.32e+05. What is the difference between the Number of refugees of Italy in 1999 and the Number of refugees of Zambia in 2010?
Provide a succinct answer. -4.18e+04. What is the difference between the Number of refugees of Dominican Republic in 1999 and the Number of refugees of India in 2011?
Offer a very short reply. -1.84e+05. What is the difference between the Number of refugees of Dominican Republic in 1999 and the Number of refugees of Italy in 2011?
Your response must be concise. -5.74e+04. What is the difference between the Number of refugees in Dominican Republic in 1999 and the Number of refugees in Zambia in 2011?
Provide a succinct answer. -4.50e+04. What is the difference between the Number of refugees in India in 1999 and the Number of refugees in Italy in 2011?
Give a very brief answer. 1.22e+05. What is the difference between the Number of refugees of India in 1999 and the Number of refugees of Zambia in 2011?
Offer a very short reply. 1.34e+05. What is the difference between the Number of refugees of Italy in 1999 and the Number of refugees of Zambia in 2011?
Make the answer very short. -3.96e+04. What is the difference between the Number of refugees of Dominican Republic in 2000 and the Number of refugees of India in 2010?
Give a very brief answer. -1.84e+05. What is the difference between the Number of refugees of Dominican Republic in 2000 and the Number of refugees of Italy in 2010?
Give a very brief answer. -5.59e+04. What is the difference between the Number of refugees in Dominican Republic in 2000 and the Number of refugees in Zambia in 2010?
Ensure brevity in your answer.  -4.73e+04. What is the difference between the Number of refugees of India in 2000 and the Number of refugees of Italy in 2010?
Ensure brevity in your answer.  1.15e+05. What is the difference between the Number of refugees of India in 2000 and the Number of refugees of Zambia in 2010?
Make the answer very short. 1.23e+05. What is the difference between the Number of refugees of Italy in 2000 and the Number of refugees of Zambia in 2010?
Offer a very short reply. -4.10e+04. What is the difference between the Number of refugees in Dominican Republic in 2000 and the Number of refugees in India in 2011?
Provide a succinct answer. -1.85e+05. What is the difference between the Number of refugees of Dominican Republic in 2000 and the Number of refugees of Italy in 2011?
Offer a very short reply. -5.76e+04. What is the difference between the Number of refugees in Dominican Republic in 2000 and the Number of refugees in Zambia in 2011?
Provide a succinct answer. -4.51e+04. What is the difference between the Number of refugees of India in 2000 and the Number of refugees of Italy in 2011?
Make the answer very short. 1.13e+05. What is the difference between the Number of refugees in India in 2000 and the Number of refugees in Zambia in 2011?
Offer a terse response. 1.25e+05. What is the difference between the Number of refugees of Italy in 2000 and the Number of refugees of Zambia in 2011?
Ensure brevity in your answer.  -3.88e+04. What is the difference between the Number of refugees of Dominican Republic in 2010 and the Number of refugees of India in 2011?
Your response must be concise. -1.85e+05. What is the difference between the Number of refugees in Dominican Republic in 2010 and the Number of refugees in Italy in 2011?
Offer a very short reply. -5.75e+04. What is the difference between the Number of refugees of Dominican Republic in 2010 and the Number of refugees of Zambia in 2011?
Provide a succinct answer. -4.50e+04. What is the difference between the Number of refugees of India in 2010 and the Number of refugees of Italy in 2011?
Offer a terse response. 1.27e+05. What is the difference between the Number of refugees in India in 2010 and the Number of refugees in Zambia in 2011?
Provide a short and direct response. 1.39e+05. What is the difference between the Number of refugees of Italy in 2010 and the Number of refugees of Zambia in 2011?
Your answer should be compact. 1.08e+04. What is the average Number of refugees of Dominican Republic per year?
Offer a terse response. 650.75. What is the average Number of refugees of India per year?
Your response must be concise. 1.99e+05. What is the average Number of refugees in Italy per year?
Your answer should be compact. 4.23e+04. What is the average Number of refugees in Zambia per year?
Offer a terse response. 1.43e+05. In the year 1995, what is the difference between the Number of refugees in Dominican Republic and Number of refugees in India?
Offer a very short reply. -2.26e+05. In the year 1995, what is the difference between the Number of refugees of Dominican Republic and Number of refugees of Italy?
Your response must be concise. -7.33e+04. In the year 1995, what is the difference between the Number of refugees in Dominican Republic and Number of refugees in Zambia?
Your answer should be very brief. -1.29e+05. In the year 1995, what is the difference between the Number of refugees in India and Number of refugees in Italy?
Offer a terse response. 1.53e+05. In the year 1995, what is the difference between the Number of refugees of India and Number of refugees of Zambia?
Keep it short and to the point. 9.75e+04. In the year 1995, what is the difference between the Number of refugees in Italy and Number of refugees in Zambia?
Provide a short and direct response. -5.57e+04. In the year 1996, what is the difference between the Number of refugees in Dominican Republic and Number of refugees in India?
Ensure brevity in your answer.  -2.33e+05. In the year 1996, what is the difference between the Number of refugees in Dominican Republic and Number of refugees in Italy?
Give a very brief answer. -6.41e+04. In the year 1996, what is the difference between the Number of refugees of Dominican Republic and Number of refugees of Zambia?
Give a very brief answer. -1.30e+05. In the year 1996, what is the difference between the Number of refugees in India and Number of refugees in Italy?
Provide a short and direct response. 1.69e+05. In the year 1996, what is the difference between the Number of refugees in India and Number of refugees in Zambia?
Provide a succinct answer. 1.02e+05. In the year 1996, what is the difference between the Number of refugees in Italy and Number of refugees in Zambia?
Give a very brief answer. -6.64e+04. In the year 1997, what is the difference between the Number of refugees in Dominican Republic and Number of refugees in India?
Offer a very short reply. -2.22e+05. In the year 1997, what is the difference between the Number of refugees in Dominican Republic and Number of refugees in Italy?
Offer a terse response. -6.60e+04. In the year 1997, what is the difference between the Number of refugees in Dominican Republic and Number of refugees in Zambia?
Provide a short and direct response. -1.64e+05. In the year 1997, what is the difference between the Number of refugees in India and Number of refugees in Italy?
Your answer should be compact. 1.56e+05. In the year 1997, what is the difference between the Number of refugees in India and Number of refugees in Zambia?
Offer a very short reply. 5.80e+04. In the year 1997, what is the difference between the Number of refugees of Italy and Number of refugees of Zambia?
Offer a very short reply. -9.85e+04. In the year 1998, what is the difference between the Number of refugees in Dominican Republic and Number of refugees in India?
Provide a short and direct response. -1.85e+05. In the year 1998, what is the difference between the Number of refugees of Dominican Republic and Number of refugees of Italy?
Give a very brief answer. -4859. In the year 1998, what is the difference between the Number of refugees in Dominican Republic and Number of refugees in Zambia?
Your answer should be very brief. -1.68e+05. In the year 1998, what is the difference between the Number of refugees in India and Number of refugees in Italy?
Your answer should be compact. 1.80e+05. In the year 1998, what is the difference between the Number of refugees in India and Number of refugees in Zambia?
Provide a short and direct response. 1.70e+04. In the year 1998, what is the difference between the Number of refugees of Italy and Number of refugees of Zambia?
Give a very brief answer. -1.63e+05. In the year 1999, what is the difference between the Number of refugees of Dominican Republic and Number of refugees of India?
Provide a short and direct response. -1.79e+05. In the year 1999, what is the difference between the Number of refugees in Dominican Republic and Number of refugees in Italy?
Your response must be concise. -5399. In the year 1999, what is the difference between the Number of refugees of Dominican Republic and Number of refugees of Zambia?
Give a very brief answer. -2.06e+05. In the year 1999, what is the difference between the Number of refugees in India and Number of refugees in Italy?
Offer a terse response. 1.74e+05. In the year 1999, what is the difference between the Number of refugees in India and Number of refugees in Zambia?
Make the answer very short. -2.64e+04. In the year 1999, what is the difference between the Number of refugees of Italy and Number of refugees of Zambia?
Your response must be concise. -2.00e+05. In the year 2000, what is the difference between the Number of refugees in Dominican Republic and Number of refugees in India?
Provide a short and direct response. -1.70e+05. In the year 2000, what is the difference between the Number of refugees of Dominican Republic and Number of refugees of Italy?
Your answer should be compact. -6339. In the year 2000, what is the difference between the Number of refugees in Dominican Republic and Number of refugees in Zambia?
Your response must be concise. -2.50e+05. In the year 2000, what is the difference between the Number of refugees of India and Number of refugees of Italy?
Your response must be concise. 1.64e+05. In the year 2000, what is the difference between the Number of refugees in India and Number of refugees in Zambia?
Provide a short and direct response. -8.00e+04. In the year 2000, what is the difference between the Number of refugees of Italy and Number of refugees of Zambia?
Your response must be concise. -2.44e+05. In the year 2010, what is the difference between the Number of refugees in Dominican Republic and Number of refugees in India?
Ensure brevity in your answer.  -1.84e+05. In the year 2010, what is the difference between the Number of refugees of Dominican Republic and Number of refugees of Italy?
Keep it short and to the point. -5.58e+04. In the year 2010, what is the difference between the Number of refugees of Dominican Republic and Number of refugees of Zambia?
Provide a short and direct response. -4.73e+04. In the year 2010, what is the difference between the Number of refugees of India and Number of refugees of Italy?
Your answer should be very brief. 1.28e+05. In the year 2010, what is the difference between the Number of refugees in India and Number of refugees in Zambia?
Your answer should be very brief. 1.37e+05. In the year 2010, what is the difference between the Number of refugees of Italy and Number of refugees of Zambia?
Provide a short and direct response. 8540. In the year 2011, what is the difference between the Number of refugees of Dominican Republic and Number of refugees of India?
Make the answer very short. -1.85e+05. In the year 2011, what is the difference between the Number of refugees in Dominican Republic and Number of refugees in Italy?
Provide a short and direct response. -5.75e+04. In the year 2011, what is the difference between the Number of refugees in Dominican Republic and Number of refugees in Zambia?
Your answer should be compact. -4.50e+04. In the year 2011, what is the difference between the Number of refugees in India and Number of refugees in Italy?
Your answer should be compact. 1.27e+05. In the year 2011, what is the difference between the Number of refugees of India and Number of refugees of Zambia?
Keep it short and to the point. 1.39e+05. In the year 2011, what is the difference between the Number of refugees in Italy and Number of refugees in Zambia?
Make the answer very short. 1.24e+04. What is the ratio of the Number of refugees in Dominican Republic in 1995 to that in 1996?
Make the answer very short. 1.54. What is the ratio of the Number of refugees of India in 1995 to that in 1996?
Offer a very short reply. 0.97. What is the ratio of the Number of refugees of Italy in 1995 to that in 1996?
Make the answer very short. 1.15. What is the ratio of the Number of refugees in Dominican Republic in 1995 to that in 1997?
Provide a succinct answer. 1.54. What is the ratio of the Number of refugees in India in 1995 to that in 1997?
Ensure brevity in your answer.  1.02. What is the ratio of the Number of refugees of Italy in 1995 to that in 1997?
Your answer should be compact. 1.12. What is the ratio of the Number of refugees of Zambia in 1995 to that in 1997?
Give a very brief answer. 0.79. What is the ratio of the Number of refugees of Dominican Republic in 1995 to that in 1998?
Your answer should be very brief. 1.6. What is the ratio of the Number of refugees in India in 1995 to that in 1998?
Keep it short and to the point. 1.23. What is the ratio of the Number of refugees of Italy in 1995 to that in 1998?
Provide a succinct answer. 13.58. What is the ratio of the Number of refugees in Zambia in 1995 to that in 1998?
Make the answer very short. 0.77. What is the ratio of the Number of refugees in Dominican Republic in 1995 to that in 1999?
Keep it short and to the point. 1.58. What is the ratio of the Number of refugees of India in 1995 to that in 1999?
Offer a terse response. 1.26. What is the ratio of the Number of refugees in Italy in 1995 to that in 1999?
Make the answer very short. 12.33. What is the ratio of the Number of refugees of Zambia in 1995 to that in 1999?
Give a very brief answer. 0.63. What is the ratio of the Number of refugees in Dominican Republic in 1995 to that in 2000?
Your answer should be compact. 1.93. What is the ratio of the Number of refugees in India in 1995 to that in 2000?
Make the answer very short. 1.33. What is the ratio of the Number of refugees in Italy in 1995 to that in 2000?
Provide a succinct answer. 10.85. What is the ratio of the Number of refugees in Zambia in 1995 to that in 2000?
Your answer should be compact. 0.52. What is the ratio of the Number of refugees in Dominican Republic in 1995 to that in 2010?
Your answer should be very brief. 1.64. What is the ratio of the Number of refugees in India in 1995 to that in 2010?
Make the answer very short. 1.23. What is the ratio of the Number of refugees in Italy in 1995 to that in 2010?
Provide a short and direct response. 1.32. What is the ratio of the Number of refugees of Zambia in 1995 to that in 2010?
Ensure brevity in your answer.  2.72. What is the ratio of the Number of refugees of Dominican Republic in 1995 to that in 2011?
Your answer should be very brief. 1.66. What is the ratio of the Number of refugees in India in 1995 to that in 2011?
Make the answer very short. 1.23. What is the ratio of the Number of refugees of Italy in 1995 to that in 2011?
Provide a short and direct response. 1.28. What is the ratio of the Number of refugees of Zambia in 1995 to that in 2011?
Make the answer very short. 2.85. What is the ratio of the Number of refugees in Dominican Republic in 1996 to that in 1997?
Provide a short and direct response. 1. What is the ratio of the Number of refugees of India in 1996 to that in 1997?
Keep it short and to the point. 1.05. What is the ratio of the Number of refugees of Italy in 1996 to that in 1997?
Offer a very short reply. 0.97. What is the ratio of the Number of refugees of Zambia in 1996 to that in 1997?
Your answer should be very brief. 0.79. What is the ratio of the Number of refugees of Dominican Republic in 1996 to that in 1998?
Your answer should be very brief. 1.04. What is the ratio of the Number of refugees of India in 1996 to that in 1998?
Ensure brevity in your answer.  1.26. What is the ratio of the Number of refugees of Italy in 1996 to that in 1998?
Keep it short and to the point. 11.82. What is the ratio of the Number of refugees of Zambia in 1996 to that in 1998?
Make the answer very short. 0.78. What is the ratio of the Number of refugees of Dominican Republic in 1996 to that in 1999?
Your answer should be compact. 1.02. What is the ratio of the Number of refugees of India in 1996 to that in 1999?
Your response must be concise. 1.3. What is the ratio of the Number of refugees of Italy in 1996 to that in 1999?
Provide a succinct answer. 10.74. What is the ratio of the Number of refugees of Zambia in 1996 to that in 1999?
Ensure brevity in your answer.  0.64. What is the ratio of the Number of refugees of Dominican Republic in 1996 to that in 2000?
Your answer should be very brief. 1.25. What is the ratio of the Number of refugees in India in 1996 to that in 2000?
Give a very brief answer. 1.37. What is the ratio of the Number of refugees of Italy in 1996 to that in 2000?
Keep it short and to the point. 9.45. What is the ratio of the Number of refugees of Zambia in 1996 to that in 2000?
Make the answer very short. 0.52. What is the ratio of the Number of refugees in Dominican Republic in 1996 to that in 2010?
Give a very brief answer. 1.07. What is the ratio of the Number of refugees in India in 1996 to that in 2010?
Offer a very short reply. 1.26. What is the ratio of the Number of refugees of Italy in 1996 to that in 2010?
Offer a terse response. 1.15. What is the ratio of the Number of refugees of Zambia in 1996 to that in 2010?
Your answer should be compact. 2.74. What is the ratio of the Number of refugees of Dominican Republic in 1996 to that in 2011?
Offer a terse response. 1.08. What is the ratio of the Number of refugees of India in 1996 to that in 2011?
Make the answer very short. 1.26. What is the ratio of the Number of refugees in Italy in 1996 to that in 2011?
Keep it short and to the point. 1.11. What is the ratio of the Number of refugees of Zambia in 1996 to that in 2011?
Your answer should be very brief. 2.87. What is the ratio of the Number of refugees of Dominican Republic in 1997 to that in 1998?
Give a very brief answer. 1.04. What is the ratio of the Number of refugees in India in 1997 to that in 1998?
Offer a terse response. 1.2. What is the ratio of the Number of refugees of Italy in 1997 to that in 1998?
Ensure brevity in your answer.  12.17. What is the ratio of the Number of refugees of Zambia in 1997 to that in 1998?
Your answer should be compact. 0.98. What is the ratio of the Number of refugees of Dominican Republic in 1997 to that in 1999?
Provide a succinct answer. 1.02. What is the ratio of the Number of refugees in India in 1997 to that in 1999?
Ensure brevity in your answer.  1.24. What is the ratio of the Number of refugees of Italy in 1997 to that in 1999?
Provide a short and direct response. 11.06. What is the ratio of the Number of refugees of Zambia in 1997 to that in 1999?
Offer a terse response. 0.8. What is the ratio of the Number of refugees in Dominican Republic in 1997 to that in 2000?
Your response must be concise. 1.25. What is the ratio of the Number of refugees of India in 1997 to that in 2000?
Ensure brevity in your answer.  1.3. What is the ratio of the Number of refugees of Italy in 1997 to that in 2000?
Ensure brevity in your answer.  9.73. What is the ratio of the Number of refugees in Zambia in 1997 to that in 2000?
Your response must be concise. 0.66. What is the ratio of the Number of refugees of Dominican Republic in 1997 to that in 2010?
Your response must be concise. 1.07. What is the ratio of the Number of refugees in India in 1997 to that in 2010?
Provide a short and direct response. 1.21. What is the ratio of the Number of refugees in Italy in 1997 to that in 2010?
Give a very brief answer. 1.18. What is the ratio of the Number of refugees of Zambia in 1997 to that in 2010?
Offer a very short reply. 3.45. What is the ratio of the Number of refugees of Dominican Republic in 1997 to that in 2011?
Your response must be concise. 1.07. What is the ratio of the Number of refugees of India in 1997 to that in 2011?
Your response must be concise. 1.21. What is the ratio of the Number of refugees of Italy in 1997 to that in 2011?
Provide a short and direct response. 1.15. What is the ratio of the Number of refugees in Zambia in 1997 to that in 2011?
Your answer should be very brief. 3.62. What is the ratio of the Number of refugees in Dominican Republic in 1998 to that in 1999?
Offer a very short reply. 0.98. What is the ratio of the Number of refugees in India in 1998 to that in 1999?
Make the answer very short. 1.03. What is the ratio of the Number of refugees of Italy in 1998 to that in 1999?
Offer a terse response. 0.91. What is the ratio of the Number of refugees in Zambia in 1998 to that in 1999?
Offer a terse response. 0.82. What is the ratio of the Number of refugees of Dominican Republic in 1998 to that in 2000?
Your response must be concise. 1.2. What is the ratio of the Number of refugees of India in 1998 to that in 2000?
Provide a short and direct response. 1.09. What is the ratio of the Number of refugees in Italy in 1998 to that in 2000?
Make the answer very short. 0.8. What is the ratio of the Number of refugees of Zambia in 1998 to that in 2000?
Make the answer very short. 0.67. What is the ratio of the Number of refugees of Italy in 1998 to that in 2010?
Provide a short and direct response. 0.1. What is the ratio of the Number of refugees in Zambia in 1998 to that in 2010?
Give a very brief answer. 3.52. What is the ratio of the Number of refugees in Dominican Republic in 1998 to that in 2011?
Provide a short and direct response. 1.03. What is the ratio of the Number of refugees in India in 1998 to that in 2011?
Provide a succinct answer. 1. What is the ratio of the Number of refugees in Italy in 1998 to that in 2011?
Keep it short and to the point. 0.09. What is the ratio of the Number of refugees in Zambia in 1998 to that in 2011?
Make the answer very short. 3.69. What is the ratio of the Number of refugees of Dominican Republic in 1999 to that in 2000?
Provide a succinct answer. 1.23. What is the ratio of the Number of refugees of India in 1999 to that in 2000?
Make the answer very short. 1.05. What is the ratio of the Number of refugees in Italy in 1999 to that in 2000?
Keep it short and to the point. 0.88. What is the ratio of the Number of refugees in Zambia in 1999 to that in 2000?
Offer a very short reply. 0.82. What is the ratio of the Number of refugees of Dominican Republic in 1999 to that in 2010?
Give a very brief answer. 1.04. What is the ratio of the Number of refugees of India in 1999 to that in 2010?
Provide a succinct answer. 0.97. What is the ratio of the Number of refugees of Italy in 1999 to that in 2010?
Give a very brief answer. 0.11. What is the ratio of the Number of refugees in Zambia in 1999 to that in 2010?
Keep it short and to the point. 4.31. What is the ratio of the Number of refugees in Dominican Republic in 1999 to that in 2011?
Keep it short and to the point. 1.05. What is the ratio of the Number of refugees in India in 1999 to that in 2011?
Offer a terse response. 0.97. What is the ratio of the Number of refugees of Italy in 1999 to that in 2011?
Give a very brief answer. 0.1. What is the ratio of the Number of refugees in Zambia in 1999 to that in 2011?
Your answer should be compact. 4.52. What is the ratio of the Number of refugees of Dominican Republic in 2000 to that in 2010?
Provide a short and direct response. 0.85. What is the ratio of the Number of refugees of India in 2000 to that in 2010?
Give a very brief answer. 0.92. What is the ratio of the Number of refugees of Italy in 2000 to that in 2010?
Ensure brevity in your answer.  0.12. What is the ratio of the Number of refugees of Zambia in 2000 to that in 2010?
Offer a very short reply. 5.24. What is the ratio of the Number of refugees in Dominican Republic in 2000 to that in 2011?
Your answer should be compact. 0.86. What is the ratio of the Number of refugees of India in 2000 to that in 2011?
Your answer should be very brief. 0.92. What is the ratio of the Number of refugees of Italy in 2000 to that in 2011?
Give a very brief answer. 0.12. What is the ratio of the Number of refugees in Zambia in 2000 to that in 2011?
Keep it short and to the point. 5.5. What is the ratio of the Number of refugees of Italy in 2010 to that in 2011?
Provide a short and direct response. 0.97. What is the ratio of the Number of refugees in Zambia in 2010 to that in 2011?
Offer a terse response. 1.05. What is the difference between the highest and the second highest Number of refugees in Dominican Republic?
Keep it short and to the point. 345. What is the difference between the highest and the second highest Number of refugees of India?
Your answer should be compact. 5890. What is the difference between the highest and the second highest Number of refugees in Italy?
Make the answer very short. 7682. What is the difference between the highest and the second highest Number of refugees in Zambia?
Give a very brief answer. 4.46e+04. What is the difference between the highest and the lowest Number of refugees of Dominican Republic?
Provide a succinct answer. 475. What is the difference between the highest and the lowest Number of refugees of India?
Offer a terse response. 6.24e+04. What is the difference between the highest and the lowest Number of refugees of Italy?
Keep it short and to the point. 6.88e+04. What is the difference between the highest and the lowest Number of refugees in Zambia?
Your response must be concise. 2.05e+05. 